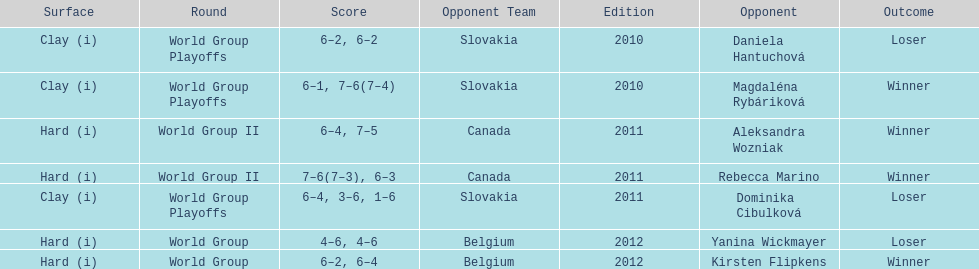Did they beat canada in more or less than 3 matches? Less. 